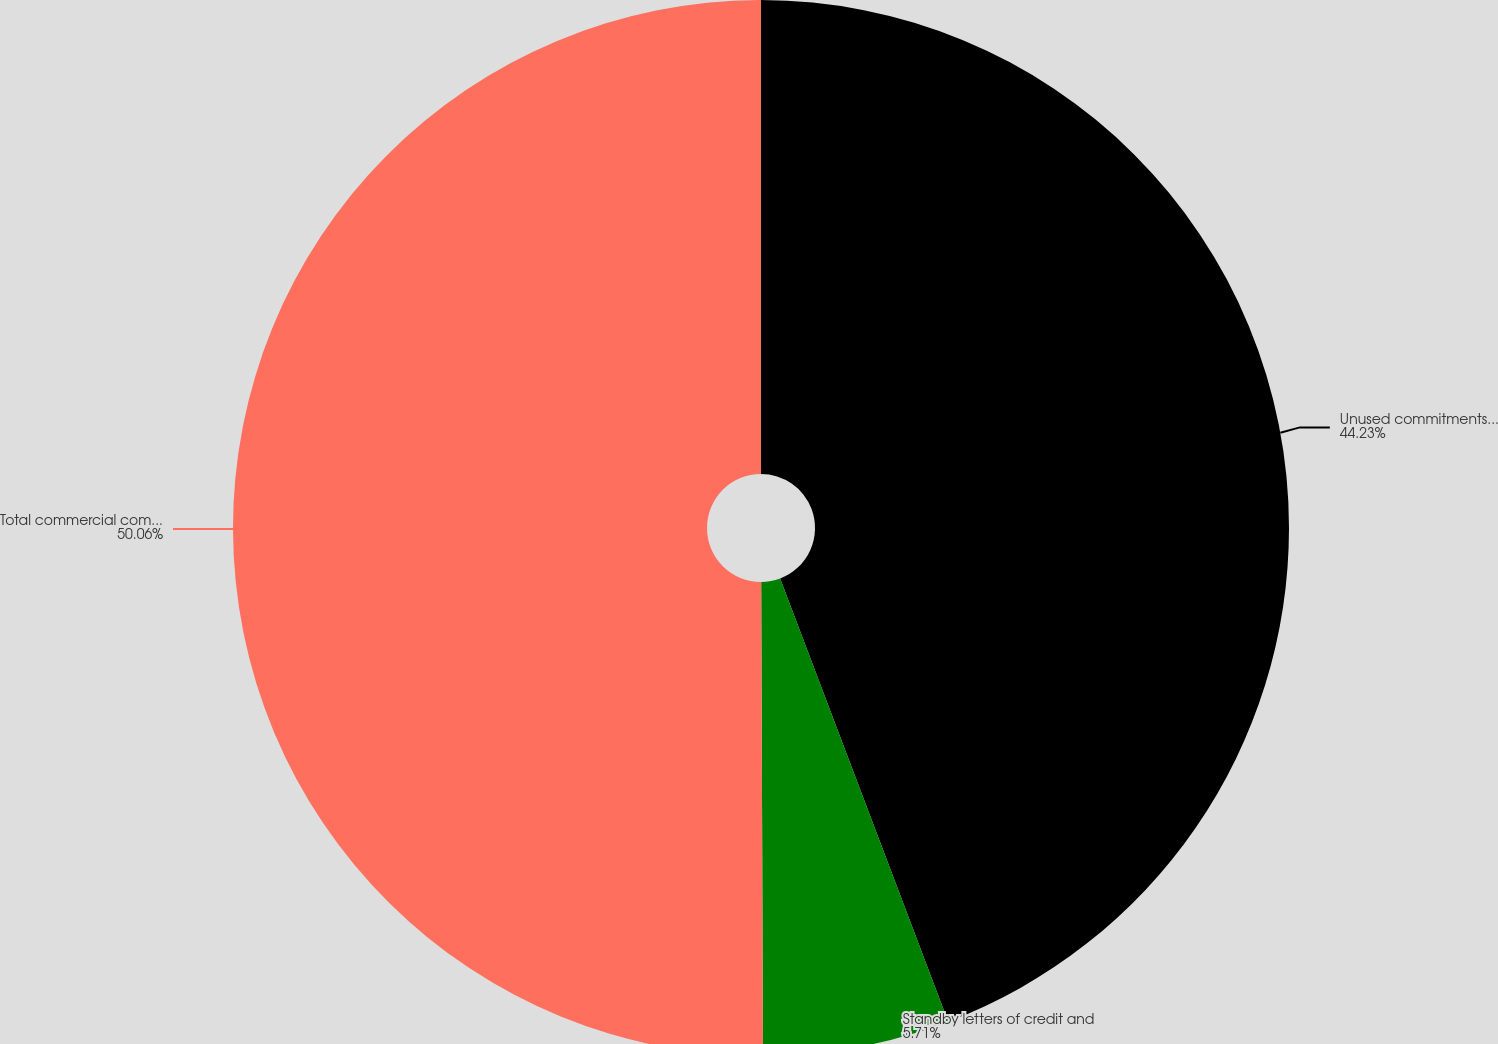Convert chart. <chart><loc_0><loc_0><loc_500><loc_500><pie_chart><fcel>Unused commitments to extend<fcel>Standby letters of credit and<fcel>Total commercial commitments<nl><fcel>44.23%<fcel>5.71%<fcel>50.06%<nl></chart> 